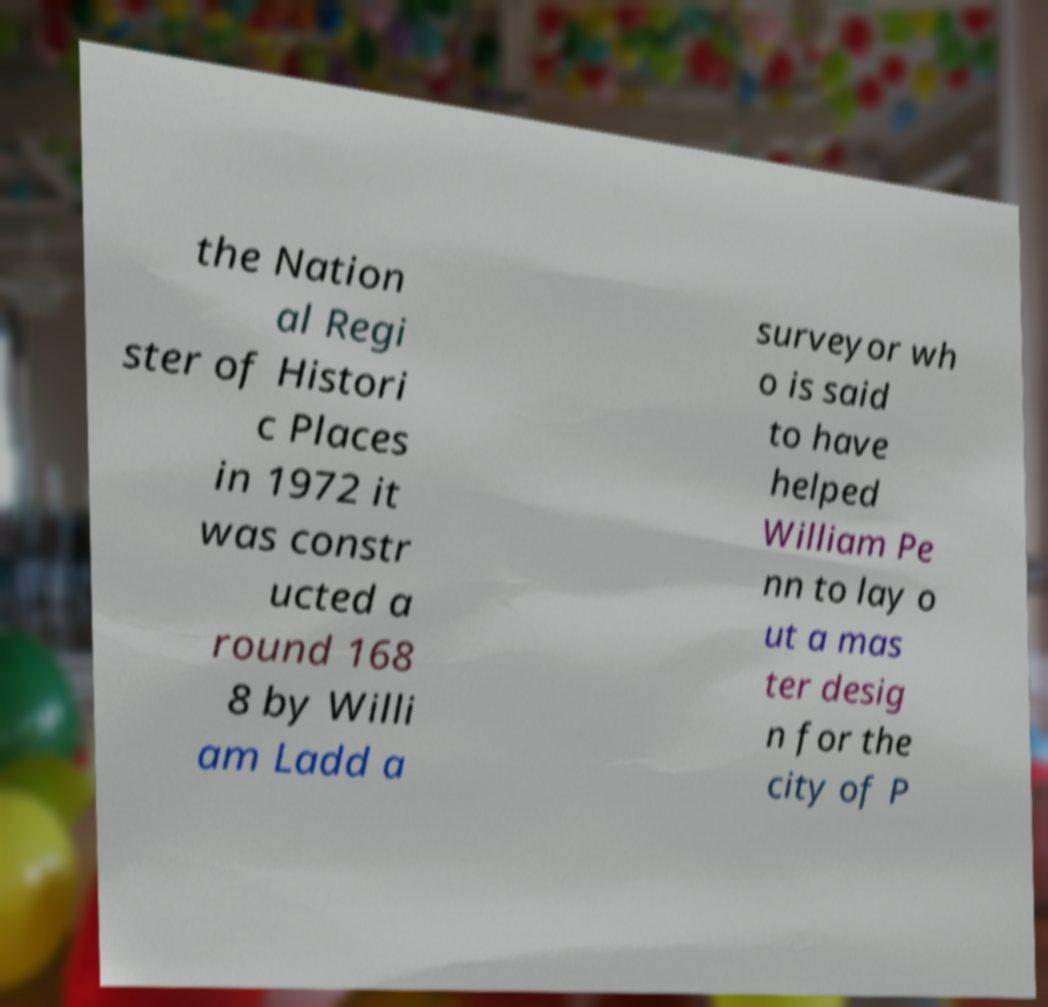I need the written content from this picture converted into text. Can you do that? the Nation al Regi ster of Histori c Places in 1972 it was constr ucted a round 168 8 by Willi am Ladd a surveyor wh o is said to have helped William Pe nn to lay o ut a mas ter desig n for the city of P 